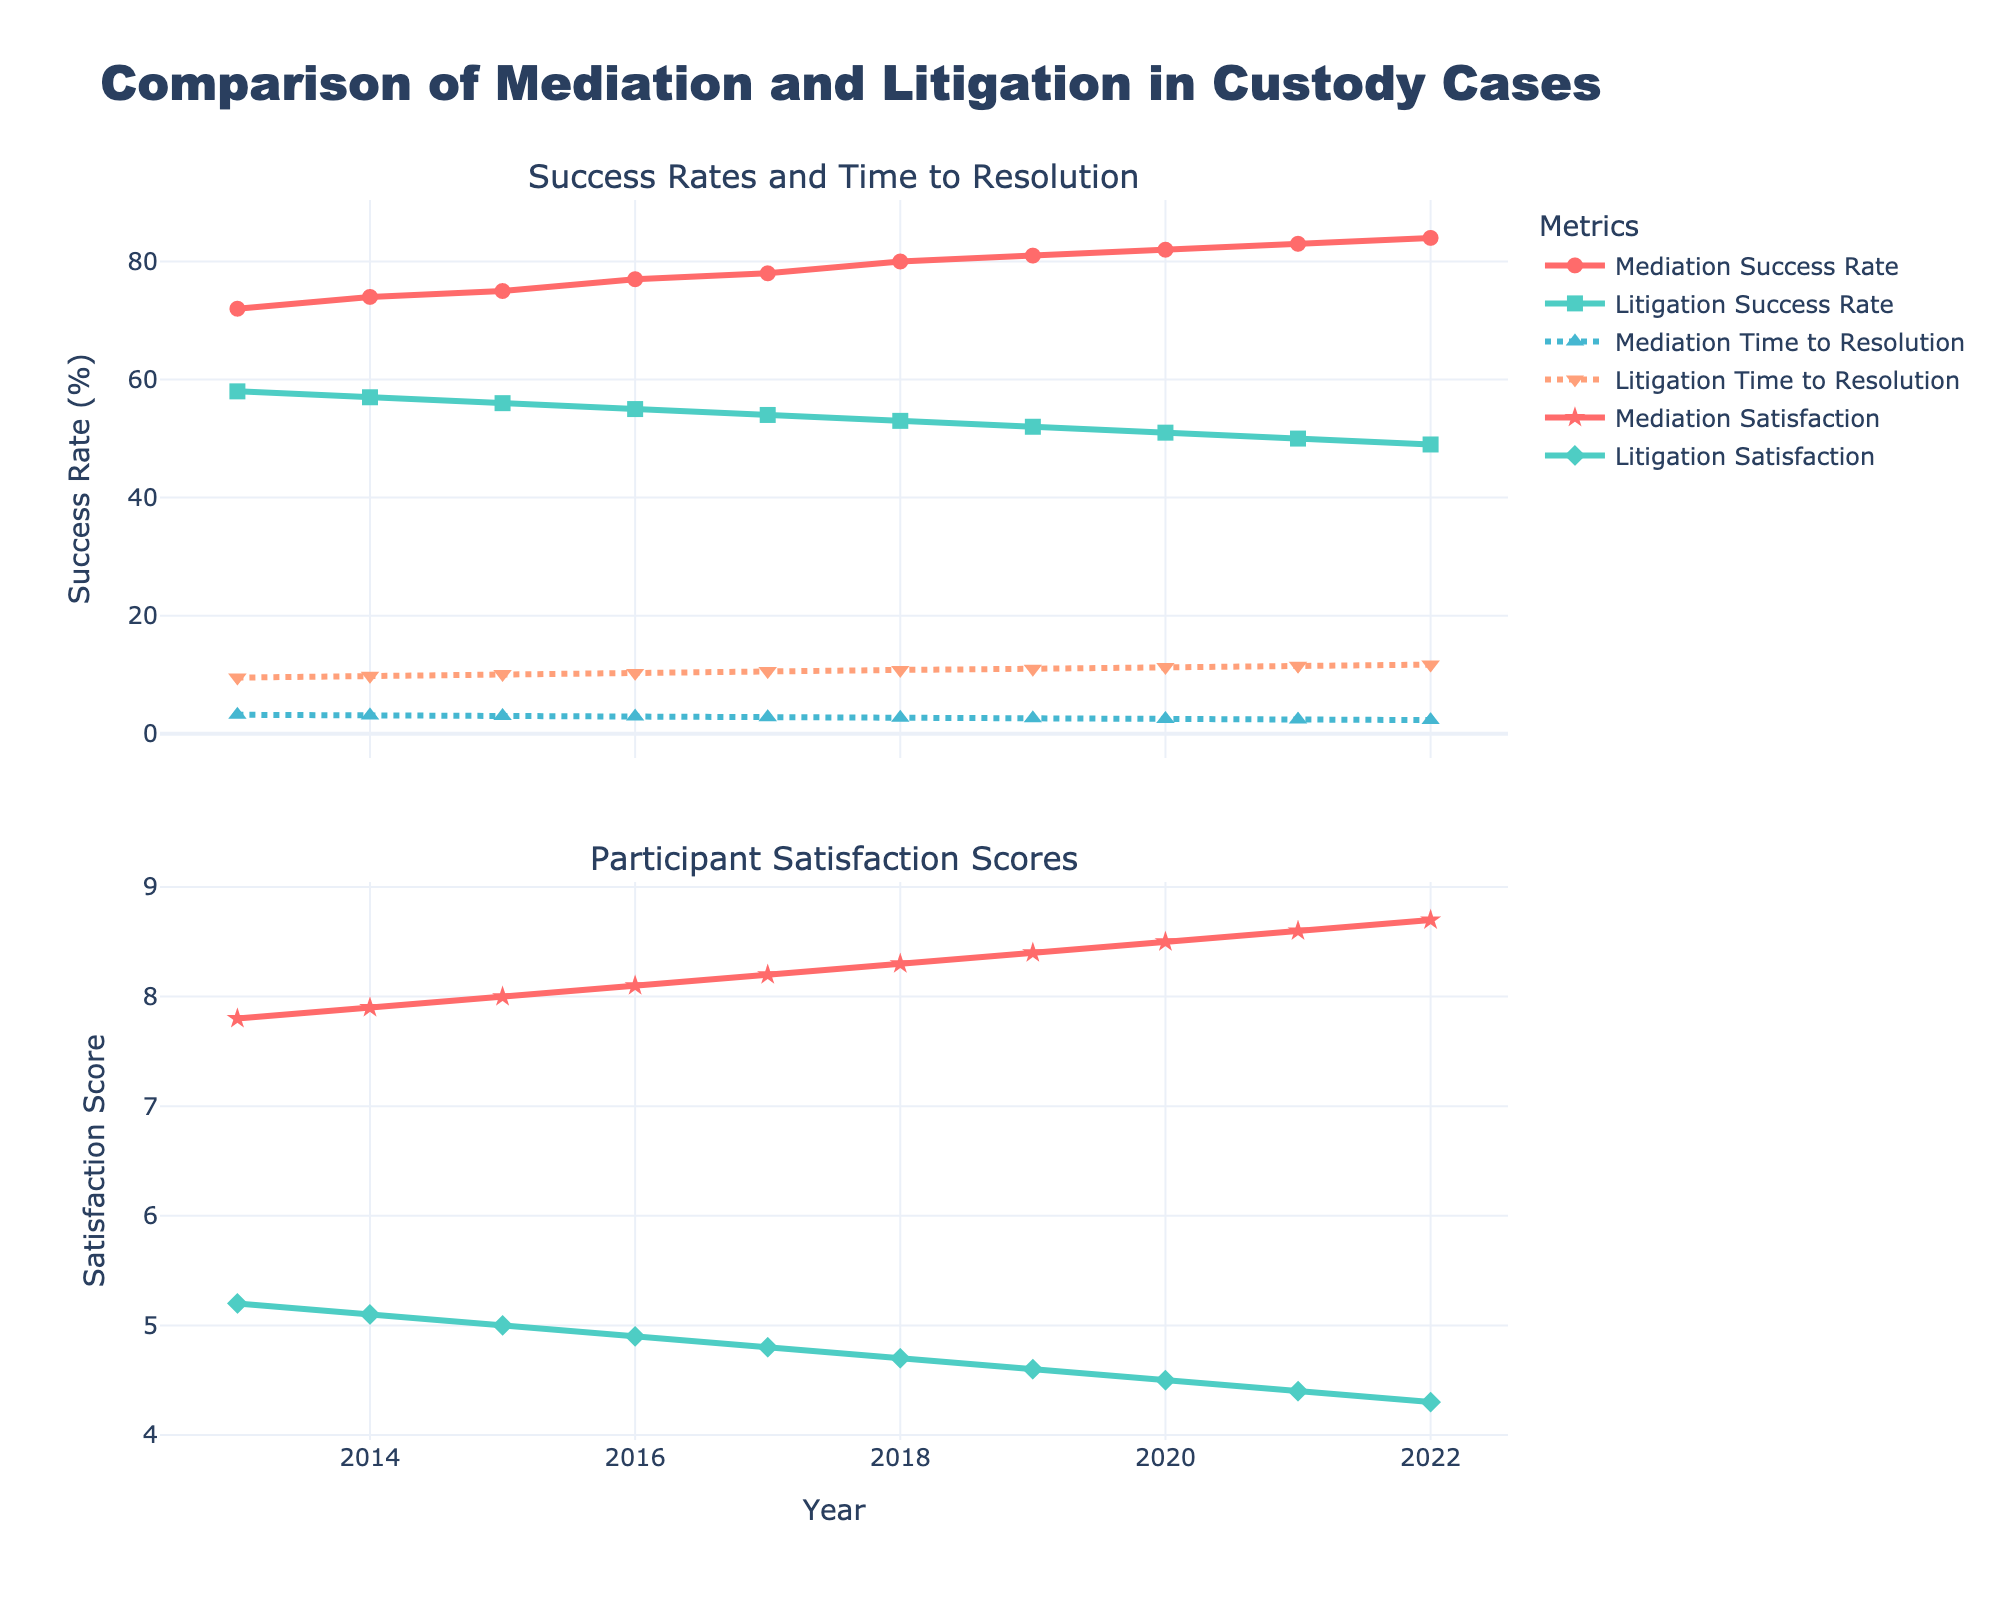What is the trend of Mediation Success Rate over the years? The Mediation Success Rate shows a general upward trend from 72% in 2013 to 84% in 2022.
Answer: Upward trend How does the Litigations Time to Resolution in 2015 compare to that of Mediation Time to Resolution in the same year? In 2015, the Litigation Time to Resolution was 10.1 months, while the Mediation Time to Resolution was 3.0 months. Comparatively, litigation took significantly longer.
Answer: Litigation took longer What is the average Mediation Satisfaction Score from 2013 to 2022? To find the average, sum the Mediation Satisfaction Scores from 2013 to 2022 (7.8 + 7.9 + 8.0 + 8.1 + 8.2 + 8.3 + 8.4 + 8.5 + 8.6 + 8.7 = 81.5) and divide by 10 (years). The average Mediation Satisfaction Score is 8.15.
Answer: 8.15 By how much did the Mediation Time to Resolution decrease from 2013 to 2022? In 2013, the Mediation Time to Resolution was 3.2 months. In 2022, it was 2.3 months. The decrease is 3.2 - 2.3 = 0.9 months.
Answer: 0.9 months In which year did the Litigation Satisfaction Score hit its minimum, and what was that score? The Litigation Satisfaction Score reached its minimum in 2022 with a score of 4.3.
Answer: 2022, 4.3 Compare the satisfaction scores of Mediation and Litigation in 2018 and explain the difference. In 2018, the Mediation Satisfaction Score was 8.3, and the Litigation Satisfaction Score was 4.7. The difference is 8.3 - 4.7 = 3.6, indicating that mediation was rated significantly better in terms of satisfaction.
Answer: Mediation was 3.6 points higher What can be inferred about the relationship between the Time to Resolution and Satisfaction Score for both Mediation and Litigation? Both Mediation and Litigation show that shorter Time to Resolution tends to correlate with higher Satisfaction Scores. Mediation had consistently shorter times and higher satisfaction compared to Litigation.
Answer: Shorter time correlates with higher satisfaction What is the most noticeable difference between Mediation and Litigation trends over the years? The most noticeable difference is that Mediation consistently shows a higher success rate, lower time to resolution, and higher satisfaction scores compared to Litigation.
Answer: Mediation consistently performs better Which metric shows the least variability over the years, and what does this indicate? The Mediation Satisfaction Score shows the least variability, steadily increasing, which indicates consistent participant satisfaction with mediation over time.
Answer: Mediation Satisfaction Score Using the figure, calculate the percentage increase in Mediation Success Rate from 2013 to 2022. The Mediation Success Rate in 2013 was 72%, and in 2022 it was 84%. The percentage increase is ((84 - 72) / 72) * 100 = 16.67%.
Answer: 16.67% 